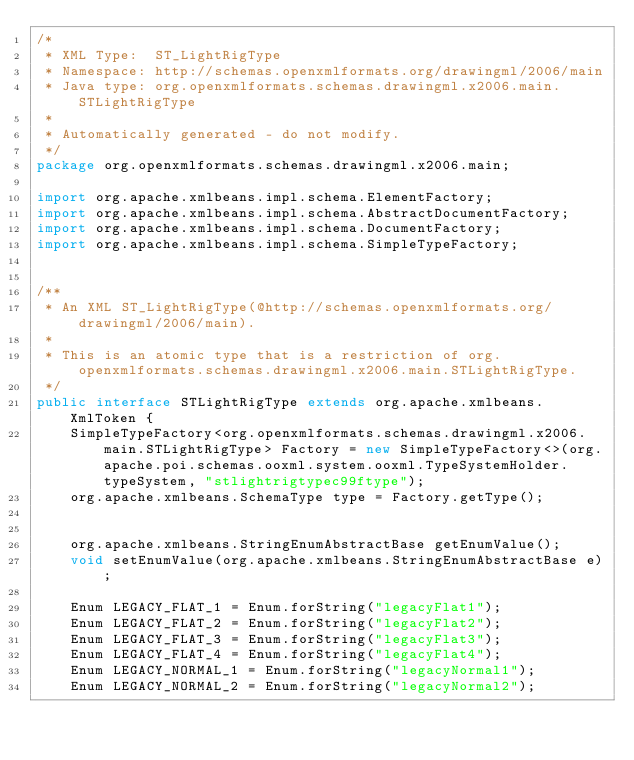<code> <loc_0><loc_0><loc_500><loc_500><_Java_>/*
 * XML Type:  ST_LightRigType
 * Namespace: http://schemas.openxmlformats.org/drawingml/2006/main
 * Java type: org.openxmlformats.schemas.drawingml.x2006.main.STLightRigType
 *
 * Automatically generated - do not modify.
 */
package org.openxmlformats.schemas.drawingml.x2006.main;

import org.apache.xmlbeans.impl.schema.ElementFactory;
import org.apache.xmlbeans.impl.schema.AbstractDocumentFactory;
import org.apache.xmlbeans.impl.schema.DocumentFactory;
import org.apache.xmlbeans.impl.schema.SimpleTypeFactory;


/**
 * An XML ST_LightRigType(@http://schemas.openxmlformats.org/drawingml/2006/main).
 *
 * This is an atomic type that is a restriction of org.openxmlformats.schemas.drawingml.x2006.main.STLightRigType.
 */
public interface STLightRigType extends org.apache.xmlbeans.XmlToken {
    SimpleTypeFactory<org.openxmlformats.schemas.drawingml.x2006.main.STLightRigType> Factory = new SimpleTypeFactory<>(org.apache.poi.schemas.ooxml.system.ooxml.TypeSystemHolder.typeSystem, "stlightrigtypec99ftype");
    org.apache.xmlbeans.SchemaType type = Factory.getType();


    org.apache.xmlbeans.StringEnumAbstractBase getEnumValue();
    void setEnumValue(org.apache.xmlbeans.StringEnumAbstractBase e);

    Enum LEGACY_FLAT_1 = Enum.forString("legacyFlat1");
    Enum LEGACY_FLAT_2 = Enum.forString("legacyFlat2");
    Enum LEGACY_FLAT_3 = Enum.forString("legacyFlat3");
    Enum LEGACY_FLAT_4 = Enum.forString("legacyFlat4");
    Enum LEGACY_NORMAL_1 = Enum.forString("legacyNormal1");
    Enum LEGACY_NORMAL_2 = Enum.forString("legacyNormal2");</code> 